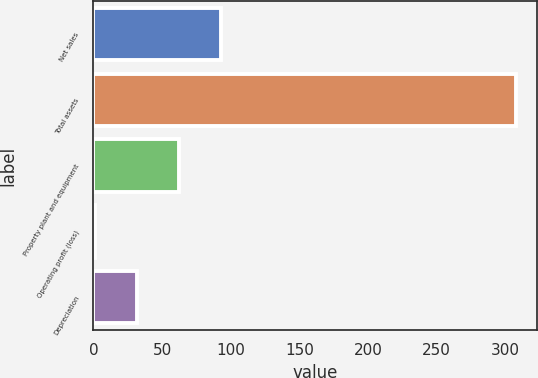Convert chart. <chart><loc_0><loc_0><loc_500><loc_500><bar_chart><fcel>Net sales<fcel>Total assets<fcel>Property plant and equipment<fcel>Operating profit (loss)<fcel>Depreciation<nl><fcel>93.1<fcel>308<fcel>62.4<fcel>1<fcel>31.7<nl></chart> 